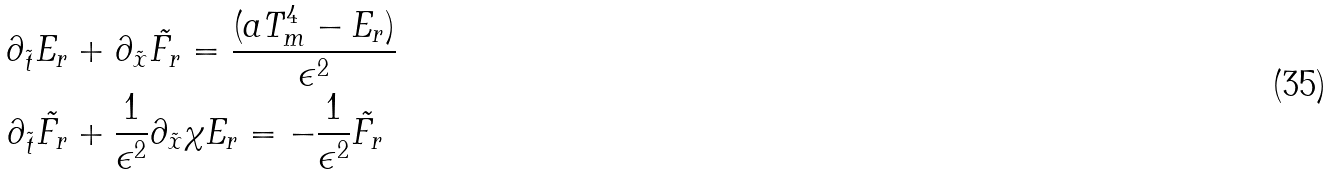Convert formula to latex. <formula><loc_0><loc_0><loc_500><loc_500>\partial _ { \tilde { t } } E _ { r } & + \partial _ { \tilde { x } } \tilde { F _ { r } } = \frac { ( a T _ { m } ^ { 4 } - E _ { r } ) } { \epsilon ^ { 2 } } \\ \partial _ { \tilde { t } } \tilde { F _ { r } } & + \frac { 1 } { \epsilon ^ { 2 } } \partial _ { \tilde { x } } \chi E _ { r } = - \frac { 1 } { \epsilon ^ { 2 } } \tilde { F _ { r } }</formula> 